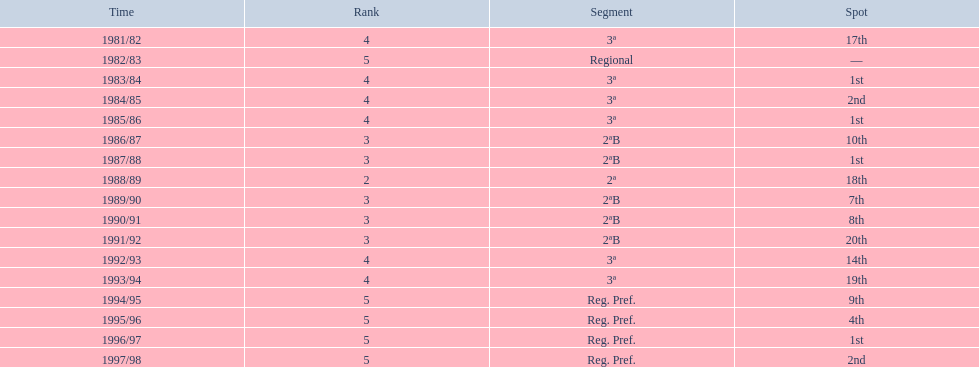How many seasons are shown in this chart? 17. 